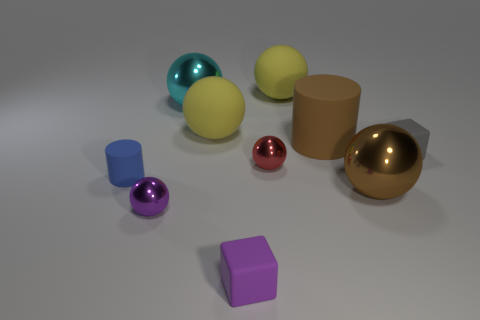Are there any small red rubber cylinders?
Provide a succinct answer. No. There is a rubber cube in front of the metallic ball to the right of the tiny red shiny object; what size is it?
Provide a succinct answer. Small. Are there more small metal objects right of the tiny purple metallic object than gray cubes right of the blue matte thing?
Keep it short and to the point. No. How many spheres are cyan metallic things or yellow objects?
Provide a short and direct response. 3. Is the shape of the large metal thing left of the red shiny object the same as  the red object?
Offer a very short reply. Yes. The small rubber cylinder has what color?
Give a very brief answer. Blue. What is the color of the other small matte thing that is the same shape as the gray thing?
Offer a very short reply. Purple. What number of blue things are the same shape as the large brown shiny thing?
Offer a very short reply. 0. What number of objects are either big yellow matte spheres or big balls to the left of the purple cube?
Keep it short and to the point. 3. There is a tiny cylinder; is its color the same as the small block left of the tiny gray rubber thing?
Your response must be concise. No. 